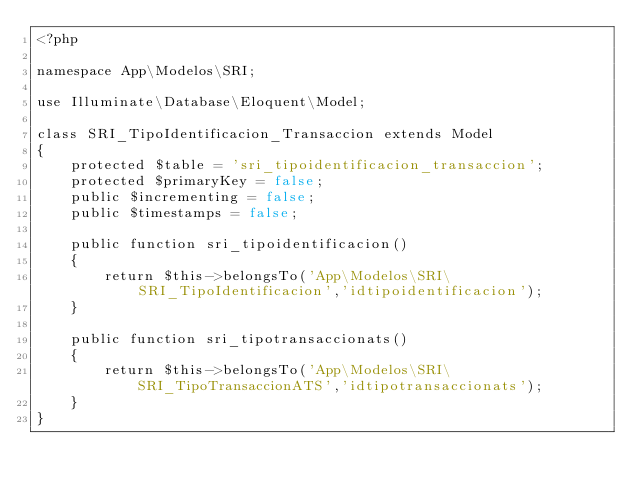<code> <loc_0><loc_0><loc_500><loc_500><_PHP_><?php

namespace App\Modelos\SRI;

use Illuminate\Database\Eloquent\Model;

class SRI_TipoIdentificacion_Transaccion extends Model
{
    protected $table = 'sri_tipoidentificacion_transaccion';
    protected $primaryKey = false;
    public $incrementing = false;
    public $timestamps = false;

    public function sri_tipoidentificacion()
    {
        return $this->belongsTo('App\Modelos\SRI\SRI_TipoIdentificacion','idtipoidentificacion');
    }

    public function sri_tipotransaccionats()
    {
        return $this->belongsTo('App\Modelos\SRI\SRI_TipoTransaccionATS','idtipotransaccionats');
    }
}
</code> 